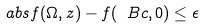<formula> <loc_0><loc_0><loc_500><loc_500>\ a b s { f ( \Omega , z ) - f ( \ B c , 0 ) } \leq \epsilon</formula> 